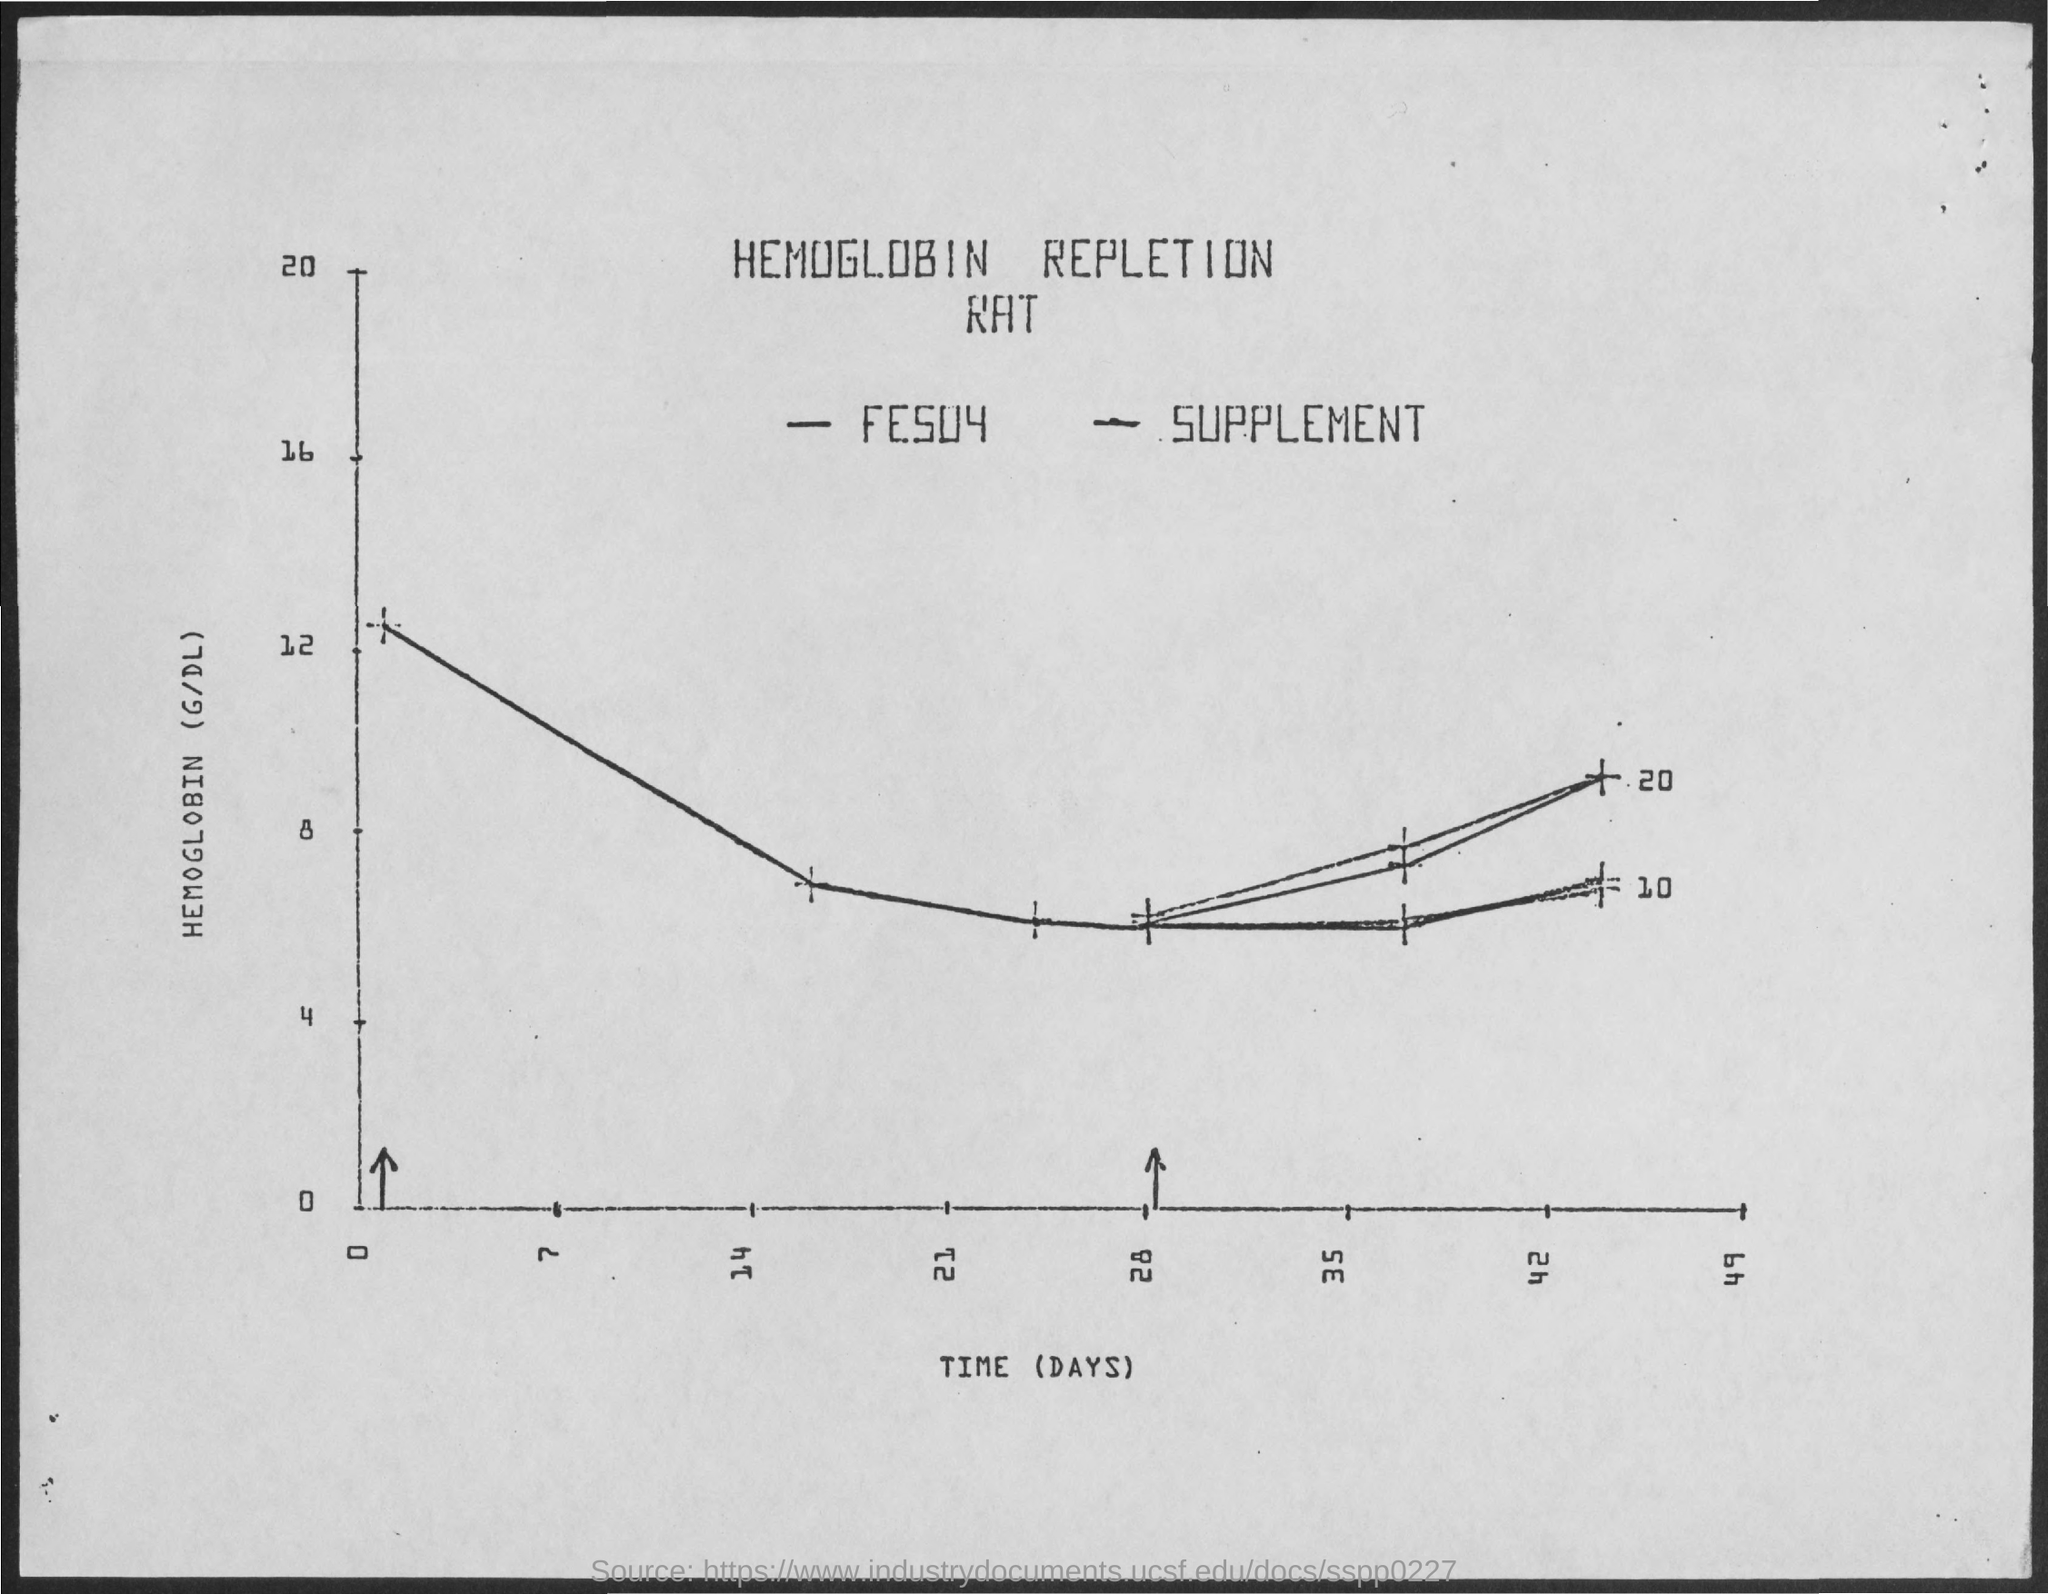Point out several critical features in this image. The x-axis displays time, measured in days. 